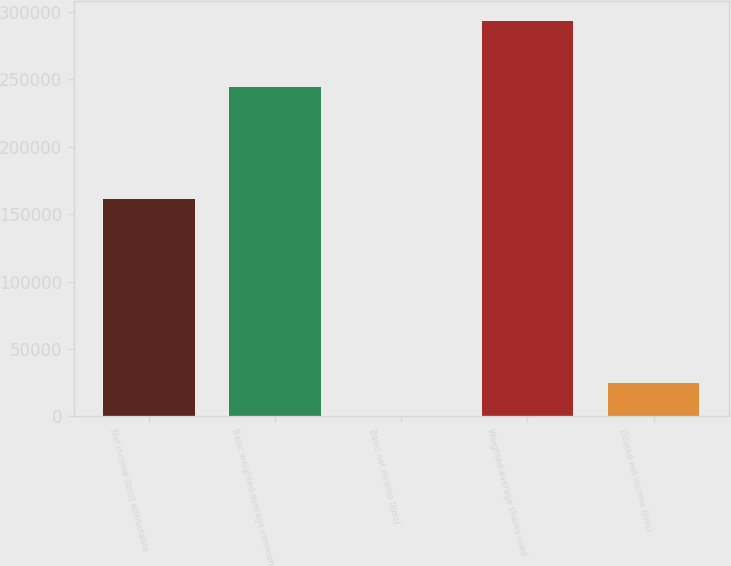Convert chart to OTSL. <chart><loc_0><loc_0><loc_500><loc_500><bar_chart><fcel>Net income (loss) attributable<fcel>Basic weighted-average common<fcel>Basic net income (loss)<fcel>Weighted-average shares used<fcel>Diluted net income (loss)<nl><fcel>160989<fcel>244685<fcel>0.46<fcel>293622<fcel>24468.9<nl></chart> 